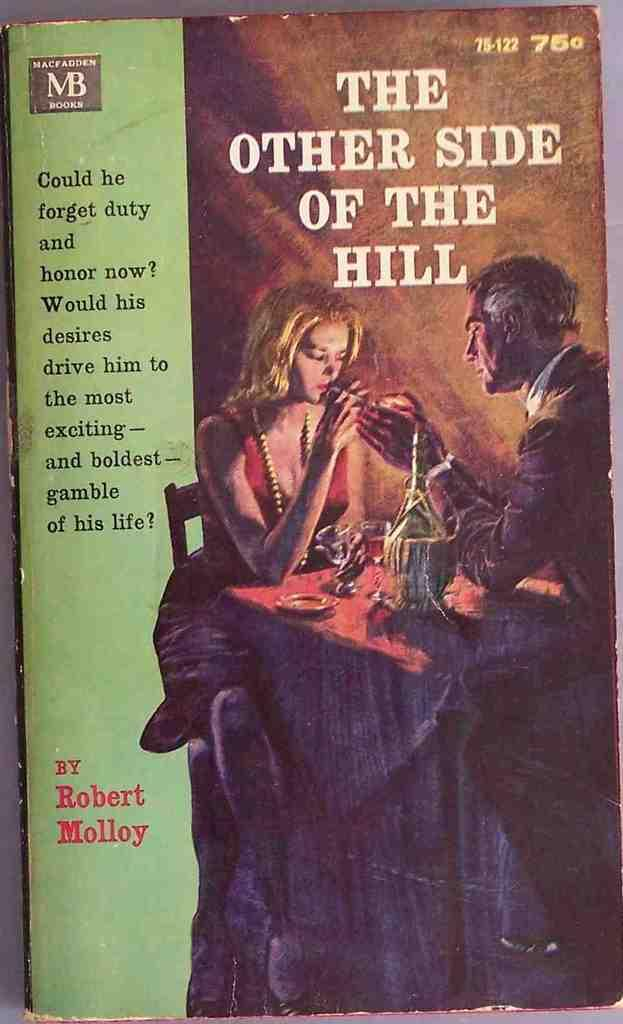<image>
Create a compact narrative representing the image presented. A book titled The Other Side of the Hill showing a man and a women sitting at a table. 